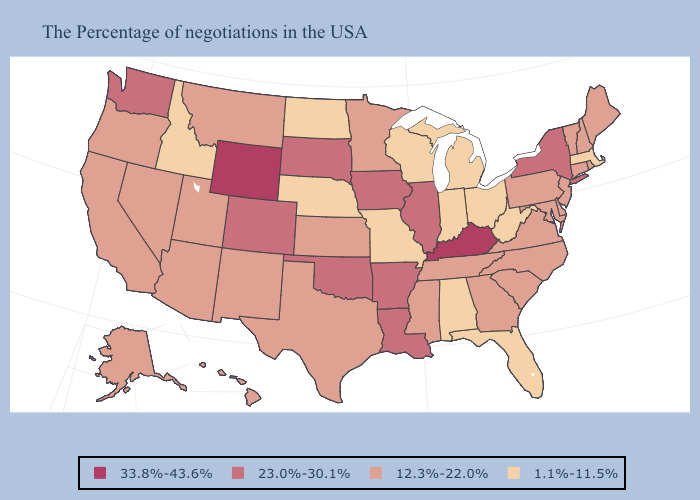What is the value of Delaware?
Give a very brief answer. 12.3%-22.0%. What is the value of Mississippi?
Short answer required. 12.3%-22.0%. Does Wyoming have the highest value in the USA?
Be succinct. Yes. Does New Jersey have the lowest value in the USA?
Answer briefly. No. How many symbols are there in the legend?
Concise answer only. 4. What is the value of Connecticut?
Short answer required. 12.3%-22.0%. What is the value of Washington?
Short answer required. 23.0%-30.1%. What is the value of Connecticut?
Concise answer only. 12.3%-22.0%. Name the states that have a value in the range 23.0%-30.1%?
Be succinct. New York, Illinois, Louisiana, Arkansas, Iowa, Oklahoma, South Dakota, Colorado, Washington. Does the first symbol in the legend represent the smallest category?
Concise answer only. No. Among the states that border South Dakota , which have the highest value?
Be succinct. Wyoming. Name the states that have a value in the range 23.0%-30.1%?
Be succinct. New York, Illinois, Louisiana, Arkansas, Iowa, Oklahoma, South Dakota, Colorado, Washington. What is the value of Michigan?
Keep it brief. 1.1%-11.5%. Name the states that have a value in the range 1.1%-11.5%?
Short answer required. Massachusetts, West Virginia, Ohio, Florida, Michigan, Indiana, Alabama, Wisconsin, Missouri, Nebraska, North Dakota, Idaho. 